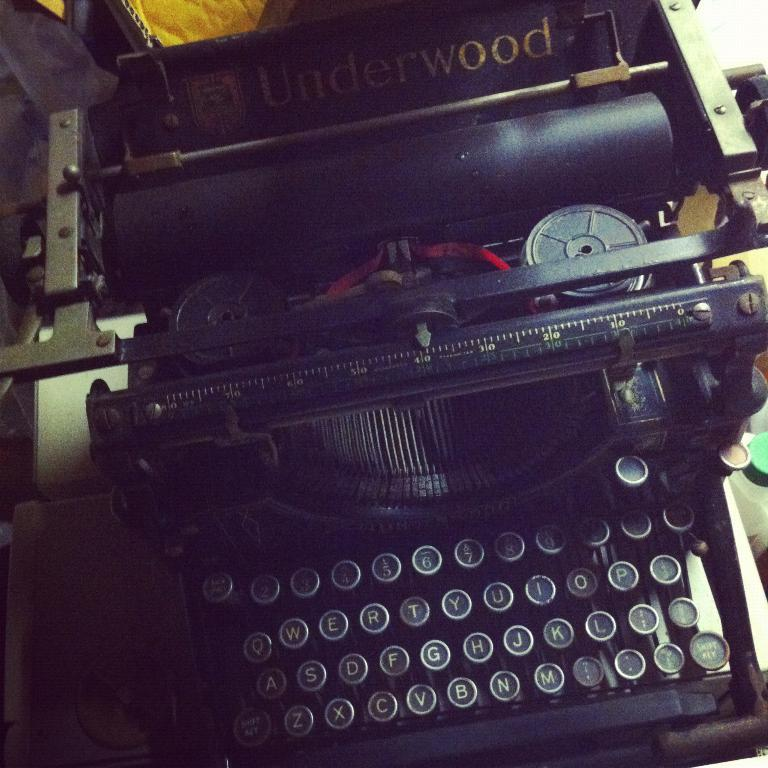<image>
Offer a succinct explanation of the picture presented. Underwood is a manufacturer of very old typewriters. 